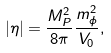Convert formula to latex. <formula><loc_0><loc_0><loc_500><loc_500>| \eta | = \frac { M _ { P } ^ { 2 } } { 8 \pi } \frac { m _ { \phi } ^ { 2 } } { V _ { 0 } } ,</formula> 